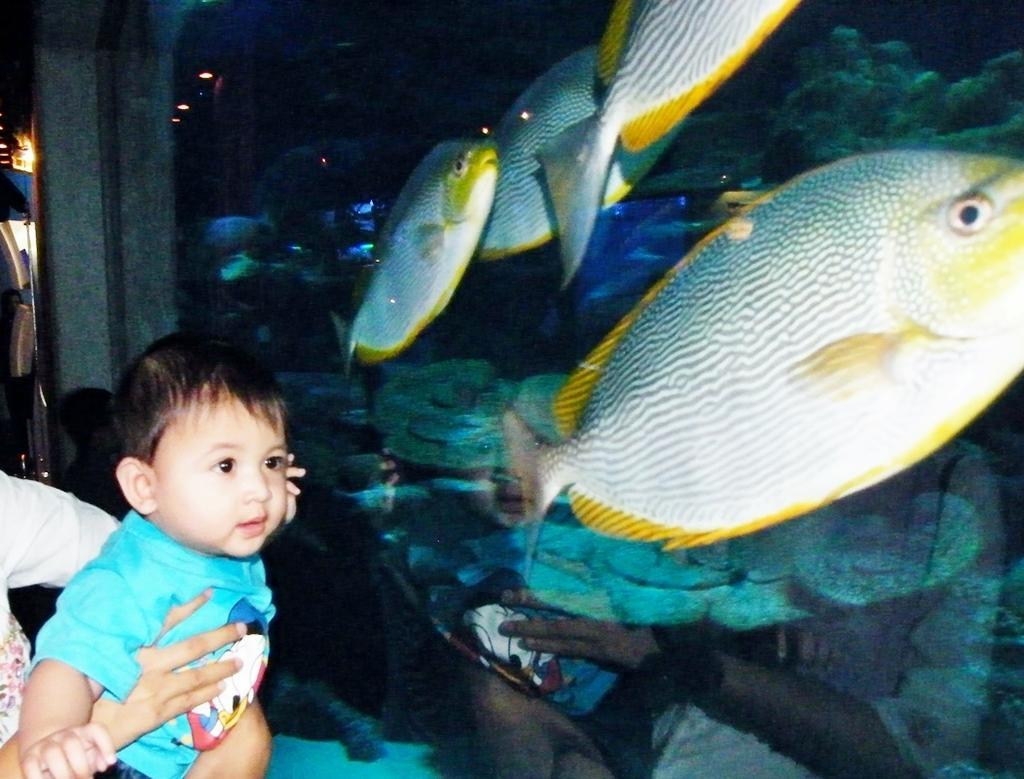How would you summarize this image in a sentence or two? In this image I can see a baby wearing blue colored dress and a person wearing white colored dress. In front of them I can see a fish tank and in the fish tank I can see few fishes which are yellow, white and grey in color. 